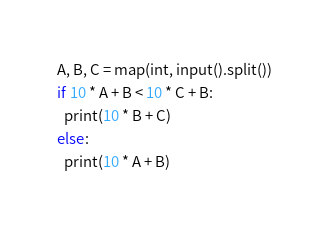<code> <loc_0><loc_0><loc_500><loc_500><_Python_>A, B, C = map(int, input().split())
if 10 * A + B < 10 * C + B:
  print(10 * B + C)
else:
  print(10 * A + B)</code> 